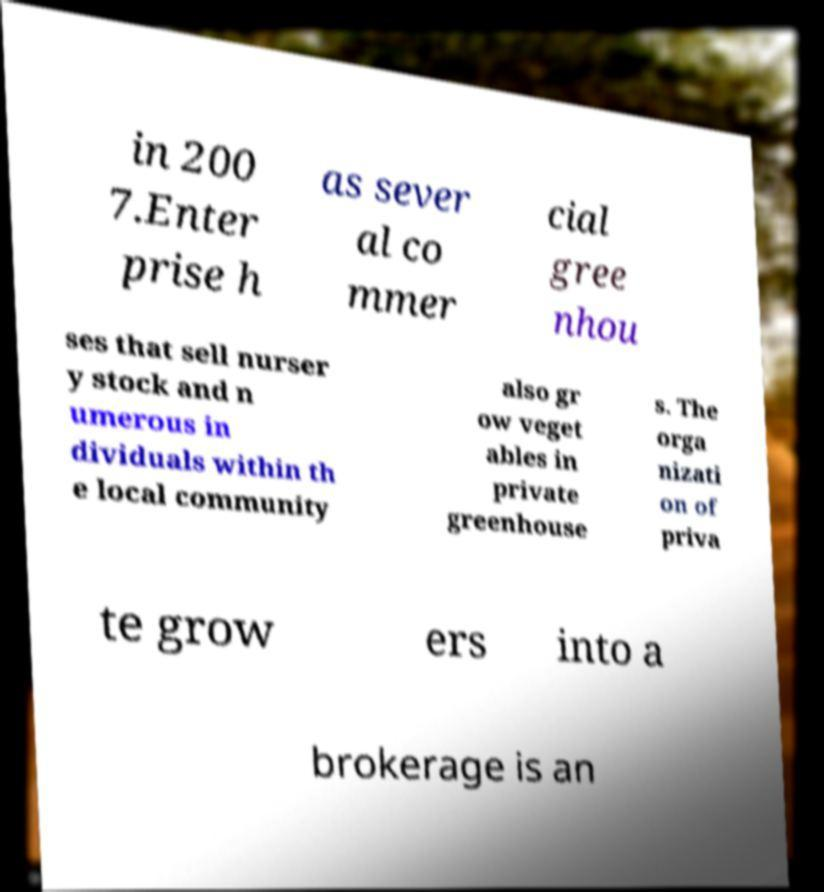What messages or text are displayed in this image? I need them in a readable, typed format. in 200 7.Enter prise h as sever al co mmer cial gree nhou ses that sell nurser y stock and n umerous in dividuals within th e local community also gr ow veget ables in private greenhouse s. The orga nizati on of priva te grow ers into a brokerage is an 